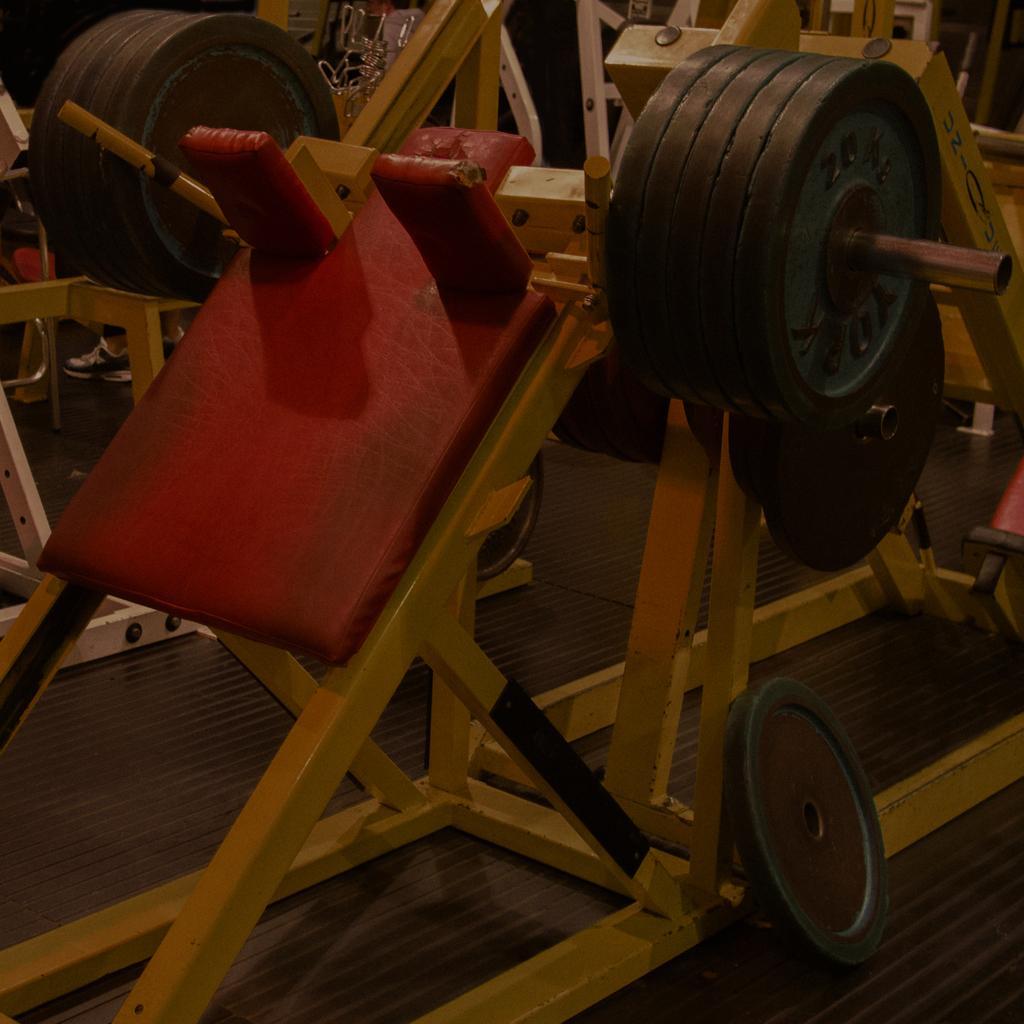How would you summarize this image in a sentence or two? In this picture we can see some gym equipments on the floor. 